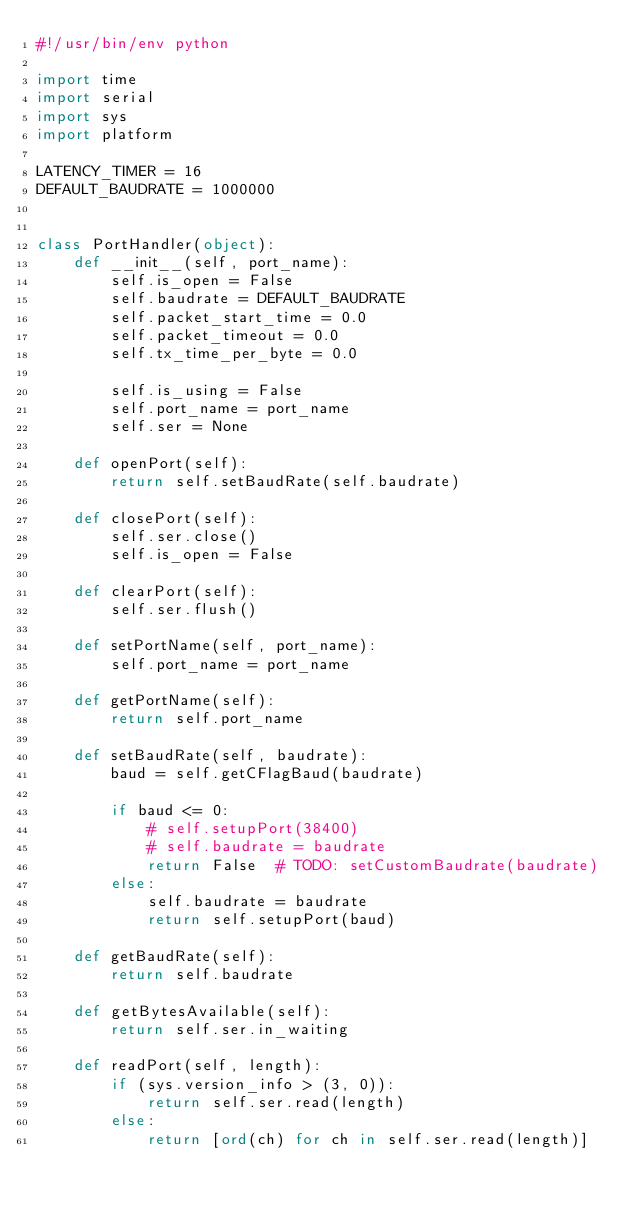<code> <loc_0><loc_0><loc_500><loc_500><_Python_>#!/usr/bin/env python

import time
import serial
import sys
import platform

LATENCY_TIMER = 16
DEFAULT_BAUDRATE = 1000000


class PortHandler(object):
    def __init__(self, port_name):
        self.is_open = False
        self.baudrate = DEFAULT_BAUDRATE
        self.packet_start_time = 0.0
        self.packet_timeout = 0.0
        self.tx_time_per_byte = 0.0

        self.is_using = False
        self.port_name = port_name
        self.ser = None

    def openPort(self):
        return self.setBaudRate(self.baudrate)

    def closePort(self):
        self.ser.close()
        self.is_open = False

    def clearPort(self):
        self.ser.flush()

    def setPortName(self, port_name):
        self.port_name = port_name

    def getPortName(self):
        return self.port_name

    def setBaudRate(self, baudrate):
        baud = self.getCFlagBaud(baudrate)

        if baud <= 0:
            # self.setupPort(38400)
            # self.baudrate = baudrate
            return False  # TODO: setCustomBaudrate(baudrate)
        else:
            self.baudrate = baudrate
            return self.setupPort(baud)

    def getBaudRate(self):
        return self.baudrate

    def getBytesAvailable(self):
        return self.ser.in_waiting

    def readPort(self, length):
        if (sys.version_info > (3, 0)):
            return self.ser.read(length)
        else:
            return [ord(ch) for ch in self.ser.read(length)]
</code> 